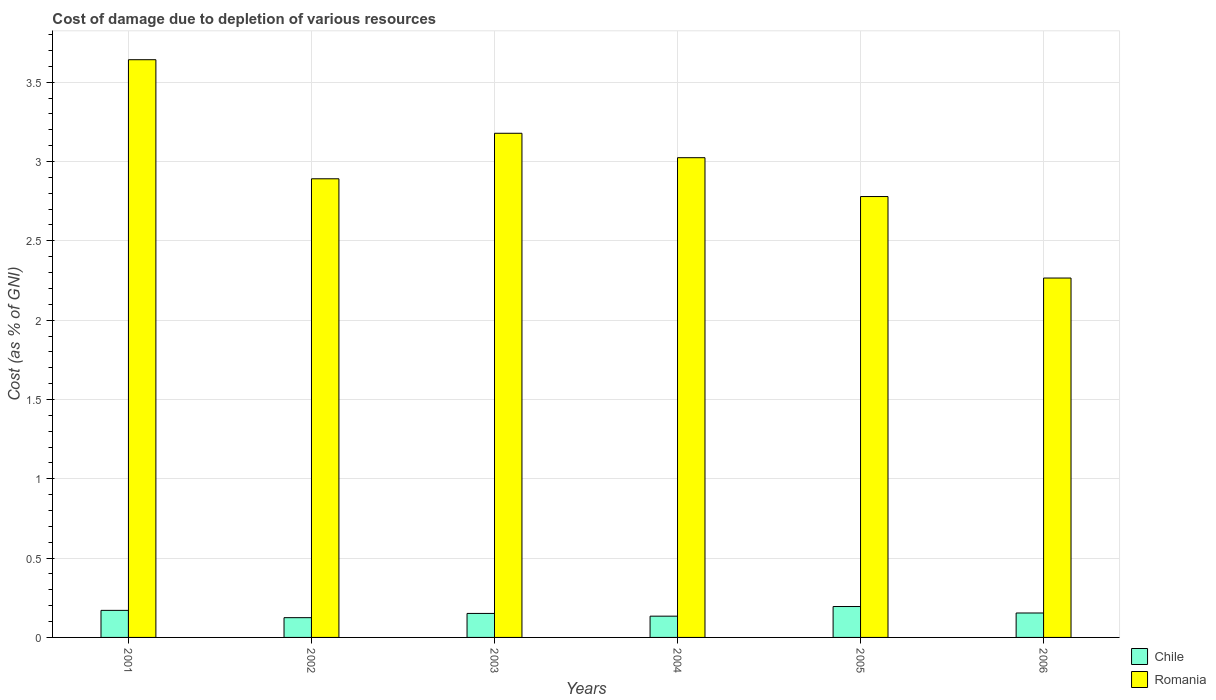How many different coloured bars are there?
Provide a short and direct response. 2. Are the number of bars per tick equal to the number of legend labels?
Make the answer very short. Yes. Are the number of bars on each tick of the X-axis equal?
Offer a terse response. Yes. How many bars are there on the 2nd tick from the left?
Offer a very short reply. 2. What is the label of the 5th group of bars from the left?
Make the answer very short. 2005. In how many cases, is the number of bars for a given year not equal to the number of legend labels?
Offer a terse response. 0. What is the cost of damage caused due to the depletion of various resources in Romania in 2001?
Provide a succinct answer. 3.64. Across all years, what is the maximum cost of damage caused due to the depletion of various resources in Chile?
Your answer should be very brief. 0.19. Across all years, what is the minimum cost of damage caused due to the depletion of various resources in Romania?
Your answer should be very brief. 2.27. In which year was the cost of damage caused due to the depletion of various resources in Chile maximum?
Offer a very short reply. 2005. In which year was the cost of damage caused due to the depletion of various resources in Romania minimum?
Your response must be concise. 2006. What is the total cost of damage caused due to the depletion of various resources in Romania in the graph?
Offer a terse response. 17.78. What is the difference between the cost of damage caused due to the depletion of various resources in Romania in 2003 and that in 2006?
Provide a succinct answer. 0.91. What is the difference between the cost of damage caused due to the depletion of various resources in Romania in 2001 and the cost of damage caused due to the depletion of various resources in Chile in 2006?
Keep it short and to the point. 3.49. What is the average cost of damage caused due to the depletion of various resources in Romania per year?
Provide a succinct answer. 2.96. In the year 2002, what is the difference between the cost of damage caused due to the depletion of various resources in Chile and cost of damage caused due to the depletion of various resources in Romania?
Make the answer very short. -2.77. In how many years, is the cost of damage caused due to the depletion of various resources in Chile greater than 2.8 %?
Give a very brief answer. 0. What is the ratio of the cost of damage caused due to the depletion of various resources in Romania in 2001 to that in 2005?
Provide a succinct answer. 1.31. Is the difference between the cost of damage caused due to the depletion of various resources in Chile in 2004 and 2005 greater than the difference between the cost of damage caused due to the depletion of various resources in Romania in 2004 and 2005?
Provide a short and direct response. No. What is the difference between the highest and the second highest cost of damage caused due to the depletion of various resources in Chile?
Provide a succinct answer. 0.02. What is the difference between the highest and the lowest cost of damage caused due to the depletion of various resources in Chile?
Provide a succinct answer. 0.07. In how many years, is the cost of damage caused due to the depletion of various resources in Romania greater than the average cost of damage caused due to the depletion of various resources in Romania taken over all years?
Ensure brevity in your answer.  3. Is the sum of the cost of damage caused due to the depletion of various resources in Romania in 2002 and 2004 greater than the maximum cost of damage caused due to the depletion of various resources in Chile across all years?
Provide a short and direct response. Yes. What does the 2nd bar from the right in 2003 represents?
Ensure brevity in your answer.  Chile. How many bars are there?
Provide a short and direct response. 12. Are all the bars in the graph horizontal?
Make the answer very short. No. Where does the legend appear in the graph?
Provide a short and direct response. Bottom right. What is the title of the graph?
Offer a very short reply. Cost of damage due to depletion of various resources. What is the label or title of the Y-axis?
Your answer should be very brief. Cost (as % of GNI). What is the Cost (as % of GNI) of Chile in 2001?
Give a very brief answer. 0.17. What is the Cost (as % of GNI) in Romania in 2001?
Offer a very short reply. 3.64. What is the Cost (as % of GNI) in Chile in 2002?
Offer a terse response. 0.12. What is the Cost (as % of GNI) of Romania in 2002?
Your answer should be compact. 2.89. What is the Cost (as % of GNI) of Chile in 2003?
Give a very brief answer. 0.15. What is the Cost (as % of GNI) in Romania in 2003?
Ensure brevity in your answer.  3.18. What is the Cost (as % of GNI) in Chile in 2004?
Make the answer very short. 0.13. What is the Cost (as % of GNI) in Romania in 2004?
Ensure brevity in your answer.  3.02. What is the Cost (as % of GNI) of Chile in 2005?
Give a very brief answer. 0.19. What is the Cost (as % of GNI) of Romania in 2005?
Keep it short and to the point. 2.78. What is the Cost (as % of GNI) in Chile in 2006?
Offer a very short reply. 0.15. What is the Cost (as % of GNI) in Romania in 2006?
Ensure brevity in your answer.  2.27. Across all years, what is the maximum Cost (as % of GNI) of Chile?
Make the answer very short. 0.19. Across all years, what is the maximum Cost (as % of GNI) of Romania?
Offer a very short reply. 3.64. Across all years, what is the minimum Cost (as % of GNI) of Chile?
Ensure brevity in your answer.  0.12. Across all years, what is the minimum Cost (as % of GNI) in Romania?
Provide a succinct answer. 2.27. What is the total Cost (as % of GNI) of Chile in the graph?
Your response must be concise. 0.93. What is the total Cost (as % of GNI) of Romania in the graph?
Make the answer very short. 17.78. What is the difference between the Cost (as % of GNI) in Chile in 2001 and that in 2002?
Provide a short and direct response. 0.05. What is the difference between the Cost (as % of GNI) in Romania in 2001 and that in 2002?
Your answer should be very brief. 0.75. What is the difference between the Cost (as % of GNI) in Chile in 2001 and that in 2003?
Give a very brief answer. 0.02. What is the difference between the Cost (as % of GNI) in Romania in 2001 and that in 2003?
Provide a short and direct response. 0.46. What is the difference between the Cost (as % of GNI) in Chile in 2001 and that in 2004?
Offer a very short reply. 0.04. What is the difference between the Cost (as % of GNI) of Romania in 2001 and that in 2004?
Your answer should be compact. 0.62. What is the difference between the Cost (as % of GNI) of Chile in 2001 and that in 2005?
Your response must be concise. -0.02. What is the difference between the Cost (as % of GNI) of Romania in 2001 and that in 2005?
Ensure brevity in your answer.  0.86. What is the difference between the Cost (as % of GNI) in Chile in 2001 and that in 2006?
Your response must be concise. 0.02. What is the difference between the Cost (as % of GNI) in Romania in 2001 and that in 2006?
Provide a short and direct response. 1.38. What is the difference between the Cost (as % of GNI) of Chile in 2002 and that in 2003?
Your answer should be very brief. -0.03. What is the difference between the Cost (as % of GNI) of Romania in 2002 and that in 2003?
Keep it short and to the point. -0.29. What is the difference between the Cost (as % of GNI) of Chile in 2002 and that in 2004?
Offer a very short reply. -0.01. What is the difference between the Cost (as % of GNI) in Romania in 2002 and that in 2004?
Ensure brevity in your answer.  -0.13. What is the difference between the Cost (as % of GNI) of Chile in 2002 and that in 2005?
Provide a short and direct response. -0.07. What is the difference between the Cost (as % of GNI) in Romania in 2002 and that in 2005?
Your answer should be compact. 0.11. What is the difference between the Cost (as % of GNI) in Chile in 2002 and that in 2006?
Ensure brevity in your answer.  -0.03. What is the difference between the Cost (as % of GNI) in Romania in 2002 and that in 2006?
Provide a succinct answer. 0.63. What is the difference between the Cost (as % of GNI) of Chile in 2003 and that in 2004?
Ensure brevity in your answer.  0.02. What is the difference between the Cost (as % of GNI) in Romania in 2003 and that in 2004?
Offer a very short reply. 0.15. What is the difference between the Cost (as % of GNI) of Chile in 2003 and that in 2005?
Provide a short and direct response. -0.04. What is the difference between the Cost (as % of GNI) in Romania in 2003 and that in 2005?
Provide a short and direct response. 0.4. What is the difference between the Cost (as % of GNI) of Chile in 2003 and that in 2006?
Provide a succinct answer. -0. What is the difference between the Cost (as % of GNI) of Romania in 2003 and that in 2006?
Your answer should be very brief. 0.91. What is the difference between the Cost (as % of GNI) in Chile in 2004 and that in 2005?
Offer a terse response. -0.06. What is the difference between the Cost (as % of GNI) of Romania in 2004 and that in 2005?
Ensure brevity in your answer.  0.24. What is the difference between the Cost (as % of GNI) in Chile in 2004 and that in 2006?
Keep it short and to the point. -0.02. What is the difference between the Cost (as % of GNI) in Romania in 2004 and that in 2006?
Your answer should be very brief. 0.76. What is the difference between the Cost (as % of GNI) of Chile in 2005 and that in 2006?
Give a very brief answer. 0.04. What is the difference between the Cost (as % of GNI) in Romania in 2005 and that in 2006?
Your answer should be compact. 0.51. What is the difference between the Cost (as % of GNI) of Chile in 2001 and the Cost (as % of GNI) of Romania in 2002?
Offer a terse response. -2.72. What is the difference between the Cost (as % of GNI) of Chile in 2001 and the Cost (as % of GNI) of Romania in 2003?
Your answer should be compact. -3.01. What is the difference between the Cost (as % of GNI) in Chile in 2001 and the Cost (as % of GNI) in Romania in 2004?
Offer a terse response. -2.85. What is the difference between the Cost (as % of GNI) in Chile in 2001 and the Cost (as % of GNI) in Romania in 2005?
Provide a short and direct response. -2.61. What is the difference between the Cost (as % of GNI) of Chile in 2001 and the Cost (as % of GNI) of Romania in 2006?
Make the answer very short. -2.09. What is the difference between the Cost (as % of GNI) of Chile in 2002 and the Cost (as % of GNI) of Romania in 2003?
Make the answer very short. -3.05. What is the difference between the Cost (as % of GNI) of Chile in 2002 and the Cost (as % of GNI) of Romania in 2004?
Your response must be concise. -2.9. What is the difference between the Cost (as % of GNI) of Chile in 2002 and the Cost (as % of GNI) of Romania in 2005?
Give a very brief answer. -2.65. What is the difference between the Cost (as % of GNI) of Chile in 2002 and the Cost (as % of GNI) of Romania in 2006?
Your answer should be compact. -2.14. What is the difference between the Cost (as % of GNI) of Chile in 2003 and the Cost (as % of GNI) of Romania in 2004?
Provide a short and direct response. -2.87. What is the difference between the Cost (as % of GNI) in Chile in 2003 and the Cost (as % of GNI) in Romania in 2005?
Provide a succinct answer. -2.63. What is the difference between the Cost (as % of GNI) of Chile in 2003 and the Cost (as % of GNI) of Romania in 2006?
Ensure brevity in your answer.  -2.11. What is the difference between the Cost (as % of GNI) of Chile in 2004 and the Cost (as % of GNI) of Romania in 2005?
Make the answer very short. -2.65. What is the difference between the Cost (as % of GNI) of Chile in 2004 and the Cost (as % of GNI) of Romania in 2006?
Offer a very short reply. -2.13. What is the difference between the Cost (as % of GNI) of Chile in 2005 and the Cost (as % of GNI) of Romania in 2006?
Make the answer very short. -2.07. What is the average Cost (as % of GNI) of Chile per year?
Offer a terse response. 0.15. What is the average Cost (as % of GNI) of Romania per year?
Give a very brief answer. 2.96. In the year 2001, what is the difference between the Cost (as % of GNI) of Chile and Cost (as % of GNI) of Romania?
Provide a succinct answer. -3.47. In the year 2002, what is the difference between the Cost (as % of GNI) in Chile and Cost (as % of GNI) in Romania?
Your answer should be compact. -2.77. In the year 2003, what is the difference between the Cost (as % of GNI) of Chile and Cost (as % of GNI) of Romania?
Your response must be concise. -3.03. In the year 2004, what is the difference between the Cost (as % of GNI) in Chile and Cost (as % of GNI) in Romania?
Provide a succinct answer. -2.89. In the year 2005, what is the difference between the Cost (as % of GNI) of Chile and Cost (as % of GNI) of Romania?
Offer a very short reply. -2.58. In the year 2006, what is the difference between the Cost (as % of GNI) of Chile and Cost (as % of GNI) of Romania?
Keep it short and to the point. -2.11. What is the ratio of the Cost (as % of GNI) in Chile in 2001 to that in 2002?
Your response must be concise. 1.37. What is the ratio of the Cost (as % of GNI) in Romania in 2001 to that in 2002?
Your response must be concise. 1.26. What is the ratio of the Cost (as % of GNI) in Chile in 2001 to that in 2003?
Make the answer very short. 1.13. What is the ratio of the Cost (as % of GNI) of Romania in 2001 to that in 2003?
Offer a very short reply. 1.15. What is the ratio of the Cost (as % of GNI) of Chile in 2001 to that in 2004?
Ensure brevity in your answer.  1.27. What is the ratio of the Cost (as % of GNI) in Romania in 2001 to that in 2004?
Your answer should be compact. 1.2. What is the ratio of the Cost (as % of GNI) in Chile in 2001 to that in 2005?
Offer a very short reply. 0.88. What is the ratio of the Cost (as % of GNI) of Romania in 2001 to that in 2005?
Keep it short and to the point. 1.31. What is the ratio of the Cost (as % of GNI) in Chile in 2001 to that in 2006?
Offer a terse response. 1.11. What is the ratio of the Cost (as % of GNI) in Romania in 2001 to that in 2006?
Offer a very short reply. 1.61. What is the ratio of the Cost (as % of GNI) of Chile in 2002 to that in 2003?
Make the answer very short. 0.82. What is the ratio of the Cost (as % of GNI) of Romania in 2002 to that in 2003?
Ensure brevity in your answer.  0.91. What is the ratio of the Cost (as % of GNI) of Chile in 2002 to that in 2004?
Provide a succinct answer. 0.93. What is the ratio of the Cost (as % of GNI) in Romania in 2002 to that in 2004?
Your answer should be compact. 0.96. What is the ratio of the Cost (as % of GNI) in Chile in 2002 to that in 2005?
Make the answer very short. 0.64. What is the ratio of the Cost (as % of GNI) of Romania in 2002 to that in 2005?
Give a very brief answer. 1.04. What is the ratio of the Cost (as % of GNI) in Chile in 2002 to that in 2006?
Give a very brief answer. 0.81. What is the ratio of the Cost (as % of GNI) in Romania in 2002 to that in 2006?
Your response must be concise. 1.28. What is the ratio of the Cost (as % of GNI) of Chile in 2003 to that in 2004?
Your answer should be compact. 1.13. What is the ratio of the Cost (as % of GNI) in Romania in 2003 to that in 2004?
Keep it short and to the point. 1.05. What is the ratio of the Cost (as % of GNI) of Chile in 2003 to that in 2005?
Provide a succinct answer. 0.78. What is the ratio of the Cost (as % of GNI) of Romania in 2003 to that in 2005?
Ensure brevity in your answer.  1.14. What is the ratio of the Cost (as % of GNI) in Chile in 2003 to that in 2006?
Keep it short and to the point. 0.98. What is the ratio of the Cost (as % of GNI) of Romania in 2003 to that in 2006?
Give a very brief answer. 1.4. What is the ratio of the Cost (as % of GNI) of Chile in 2004 to that in 2005?
Give a very brief answer. 0.69. What is the ratio of the Cost (as % of GNI) of Romania in 2004 to that in 2005?
Your answer should be very brief. 1.09. What is the ratio of the Cost (as % of GNI) of Chile in 2004 to that in 2006?
Provide a short and direct response. 0.87. What is the ratio of the Cost (as % of GNI) in Romania in 2004 to that in 2006?
Your response must be concise. 1.33. What is the ratio of the Cost (as % of GNI) of Chile in 2005 to that in 2006?
Offer a terse response. 1.26. What is the ratio of the Cost (as % of GNI) in Romania in 2005 to that in 2006?
Keep it short and to the point. 1.23. What is the difference between the highest and the second highest Cost (as % of GNI) of Chile?
Provide a short and direct response. 0.02. What is the difference between the highest and the second highest Cost (as % of GNI) in Romania?
Keep it short and to the point. 0.46. What is the difference between the highest and the lowest Cost (as % of GNI) of Chile?
Your response must be concise. 0.07. What is the difference between the highest and the lowest Cost (as % of GNI) of Romania?
Provide a short and direct response. 1.38. 